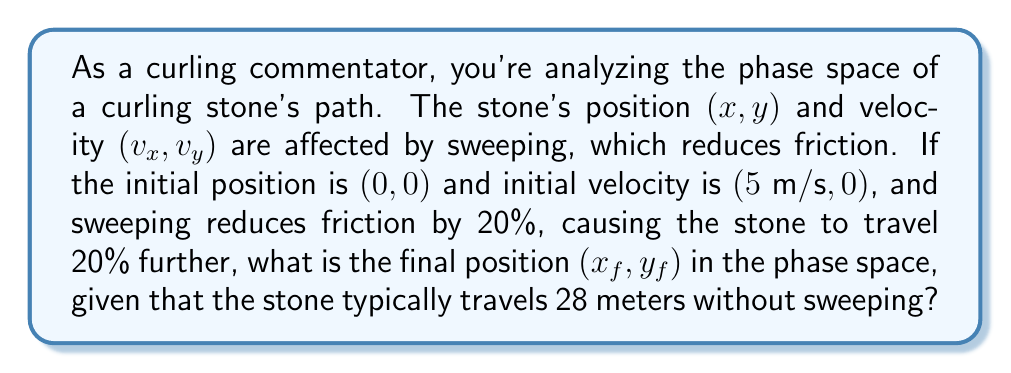Give your solution to this math problem. 1) First, let's consider the stone's path without sweeping:
   - Distance traveled = 28 meters
   - Initial velocity = $5 \text{ m/s}$ in the x-direction

2) With sweeping, the stone travels 20% further:
   $$d_{sweep} = 28 \times 1.2 = 33.6 \text{ meters}$$

3) In curling, the stone's path is approximately parabolic due to friction. We can model this using the equations of motion:
   $$x = v_0t - \frac{1}{2}at^2$$
   $$v = v_0 - at$$

   Where $v_0$ is the initial velocity, $a$ is deceleration due to friction, and $t$ is time.

4) At the end of the stone's path, $v = 0$. Using this, we can find $t$:
   $$0 = 5 - at$$
   $$t = \frac{5}{a}$$

5) Substituting this into the distance equation:
   $$33.6 = 5 \cdot \frac{5}{a} - \frac{1}{2}a \cdot (\frac{5}{a})^2$$
   $$33.6 = \frac{25}{a} - \frac{25}{2a}$$
   $$33.6 = \frac{25}{2a}$$
   $$a = \frac{25}{2 \cdot 33.6} = 0.372 \text{ m/s}^2$$

6) The final velocity $(v_x,v_y)$ in the phase space is $(0,0)$, as the stone comes to rest.

7) The final position $(x_f,y_f)$ is $(33.6,0)$, as the stone travels 33.6 meters in the x-direction and doesn't move in the y-direction.
Answer: $(33.6,0)$ 